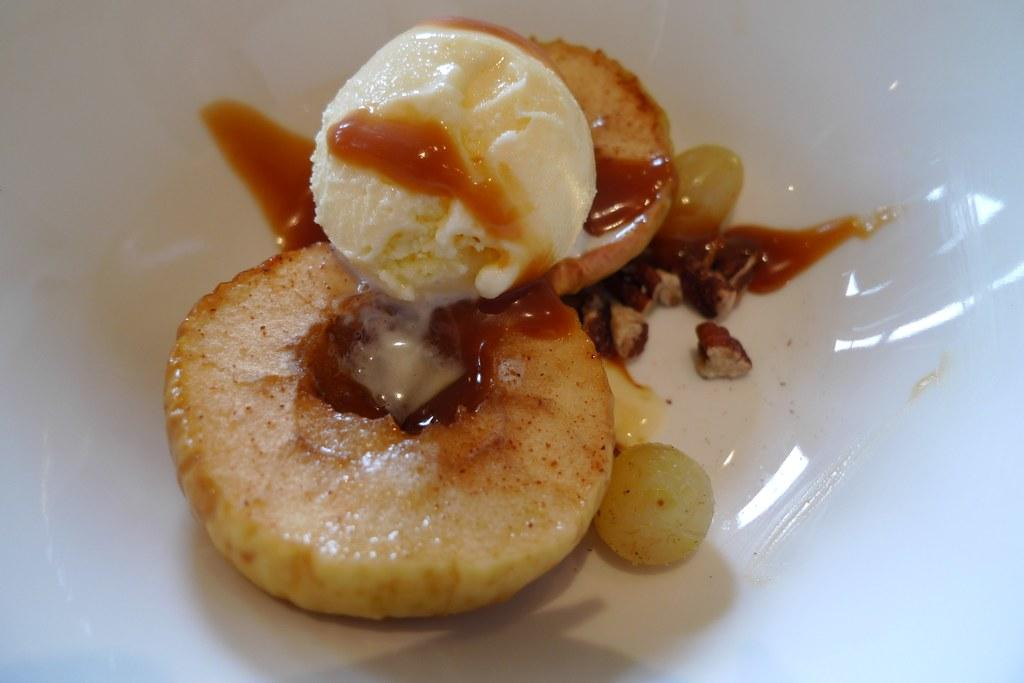What is the main subject of the image? The main subject of the image is an ice-cream. How is the ice-cream arranged in the image? The ice-cream is arranged on two pieces of fruit. Are there any other fruits visible in the image? Yes, there are two additional fruits in the image. What color is the bowl containing the ice-cream and fruit? The bowl is white in color. What type of can is visible in the image? There is no can present in the image. Can you describe the guide accompanying the fruits in the image? There is no guide present in the image; it only features ice-cream and fruit. 